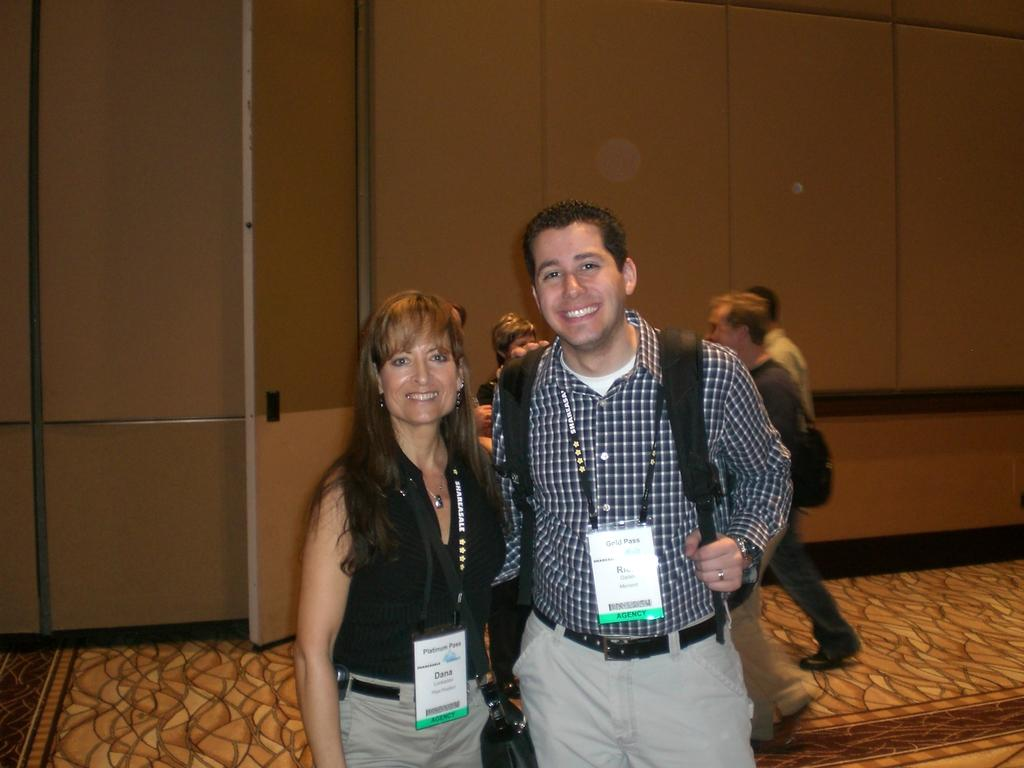Who are the two people in the center of the image? There is a man and a woman in the center of the image. What is the surface they are standing on? The man and woman are standing on the floor. Can you describe the background of the image? There are persons visible in the background of the image, and there is a wall in the background as well. What type of hen can be seen knitting with yarn in the image? There is no hen or yarn present in the image; it features a man and a woman standing on the floor with a background that includes other persons and a wall. 